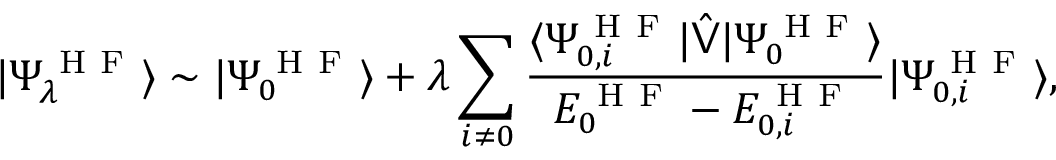Convert formula to latex. <formula><loc_0><loc_0><loc_500><loc_500>| \Psi _ { \lambda } ^ { H F } \rangle \sim | \Psi _ { 0 } ^ { H F } \rangle + \lambda \sum _ { i \neq 0 } \frac { \langle \Psi _ { 0 , i } ^ { H F } | \hat { V } | \Psi _ { 0 } ^ { H F } \rangle } { E _ { 0 } ^ { H F } - E _ { 0 , i } ^ { H F } } | \Psi _ { 0 , i } ^ { H F } \rangle ,</formula> 